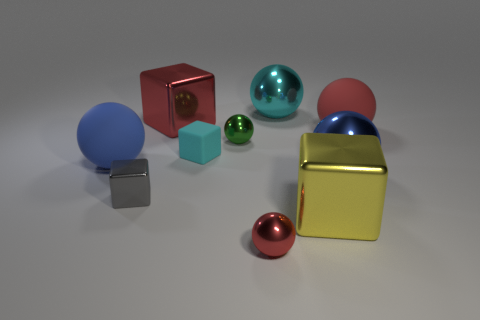Subtract all cyan cubes. How many cubes are left? 3 Subtract all cyan blocks. How many blocks are left? 3 Subtract 0 purple balls. How many objects are left? 10 Subtract all cubes. How many objects are left? 6 Subtract 3 balls. How many balls are left? 3 Subtract all brown blocks. Subtract all blue cylinders. How many blocks are left? 4 Subtract all red cubes. How many red balls are left? 2 Subtract all blue metal cubes. Subtract all big blocks. How many objects are left? 8 Add 1 small things. How many small things are left? 5 Add 9 small cyan matte blocks. How many small cyan matte blocks exist? 10 